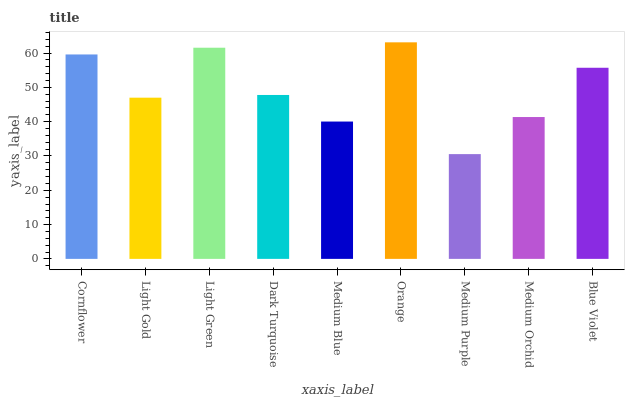Is Medium Purple the minimum?
Answer yes or no. Yes. Is Orange the maximum?
Answer yes or no. Yes. Is Light Gold the minimum?
Answer yes or no. No. Is Light Gold the maximum?
Answer yes or no. No. Is Cornflower greater than Light Gold?
Answer yes or no. Yes. Is Light Gold less than Cornflower?
Answer yes or no. Yes. Is Light Gold greater than Cornflower?
Answer yes or no. No. Is Cornflower less than Light Gold?
Answer yes or no. No. Is Dark Turquoise the high median?
Answer yes or no. Yes. Is Dark Turquoise the low median?
Answer yes or no. Yes. Is Light Gold the high median?
Answer yes or no. No. Is Orange the low median?
Answer yes or no. No. 